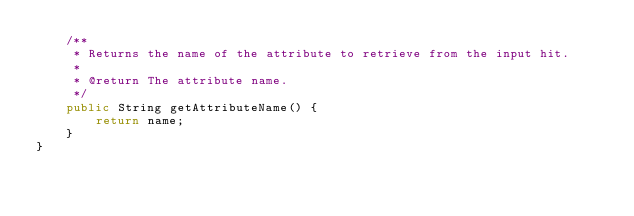Convert code to text. <code><loc_0><loc_0><loc_500><loc_500><_Java_>    /**
     * Returns the name of the attribute to retrieve from the input hit.
     *
     * @return The attribute name.
     */
    public String getAttributeName() {
        return name;
    }
}
</code> 